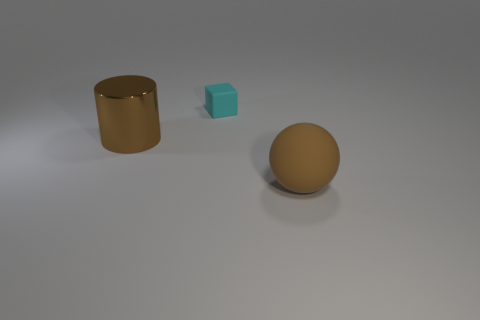Is there a relation between the objects in terms of size? Yes, the objects seem to be arranged in ascending order of size, with the cyan block being the smallest, followed by the sphere, and then the cylindrical object as the largest. 